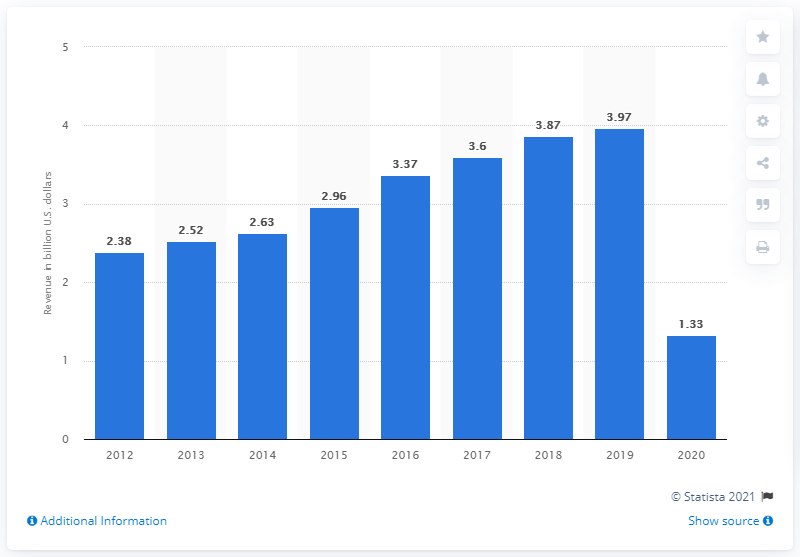Outline some significant characteristics in this image. The median value of all the bars is 2.96. In the years 2015 and 2016, there was an increase in revenue of more than 0.3 billion. In 2012, Sabre Corporation's revenue was 3.97 billion dollars. In 2020, Sabre Corporation generated approximately 1.33 billion US dollars in revenue. 